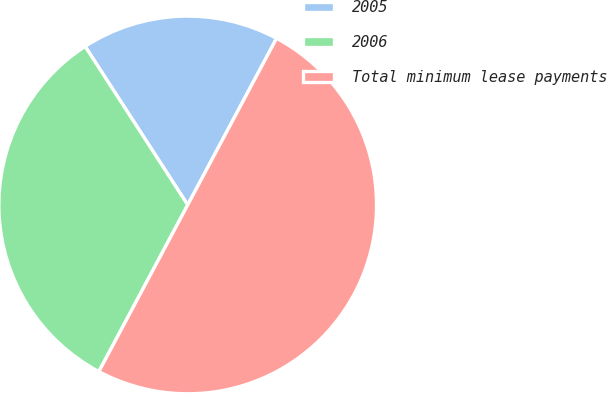Convert chart to OTSL. <chart><loc_0><loc_0><loc_500><loc_500><pie_chart><fcel>2005<fcel>2006<fcel>Total minimum lease payments<nl><fcel>16.94%<fcel>33.06%<fcel>50.0%<nl></chart> 